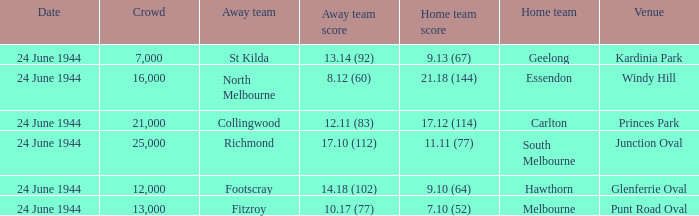When Essendon was the Home Team, what was the Away Team score? 8.12 (60). 